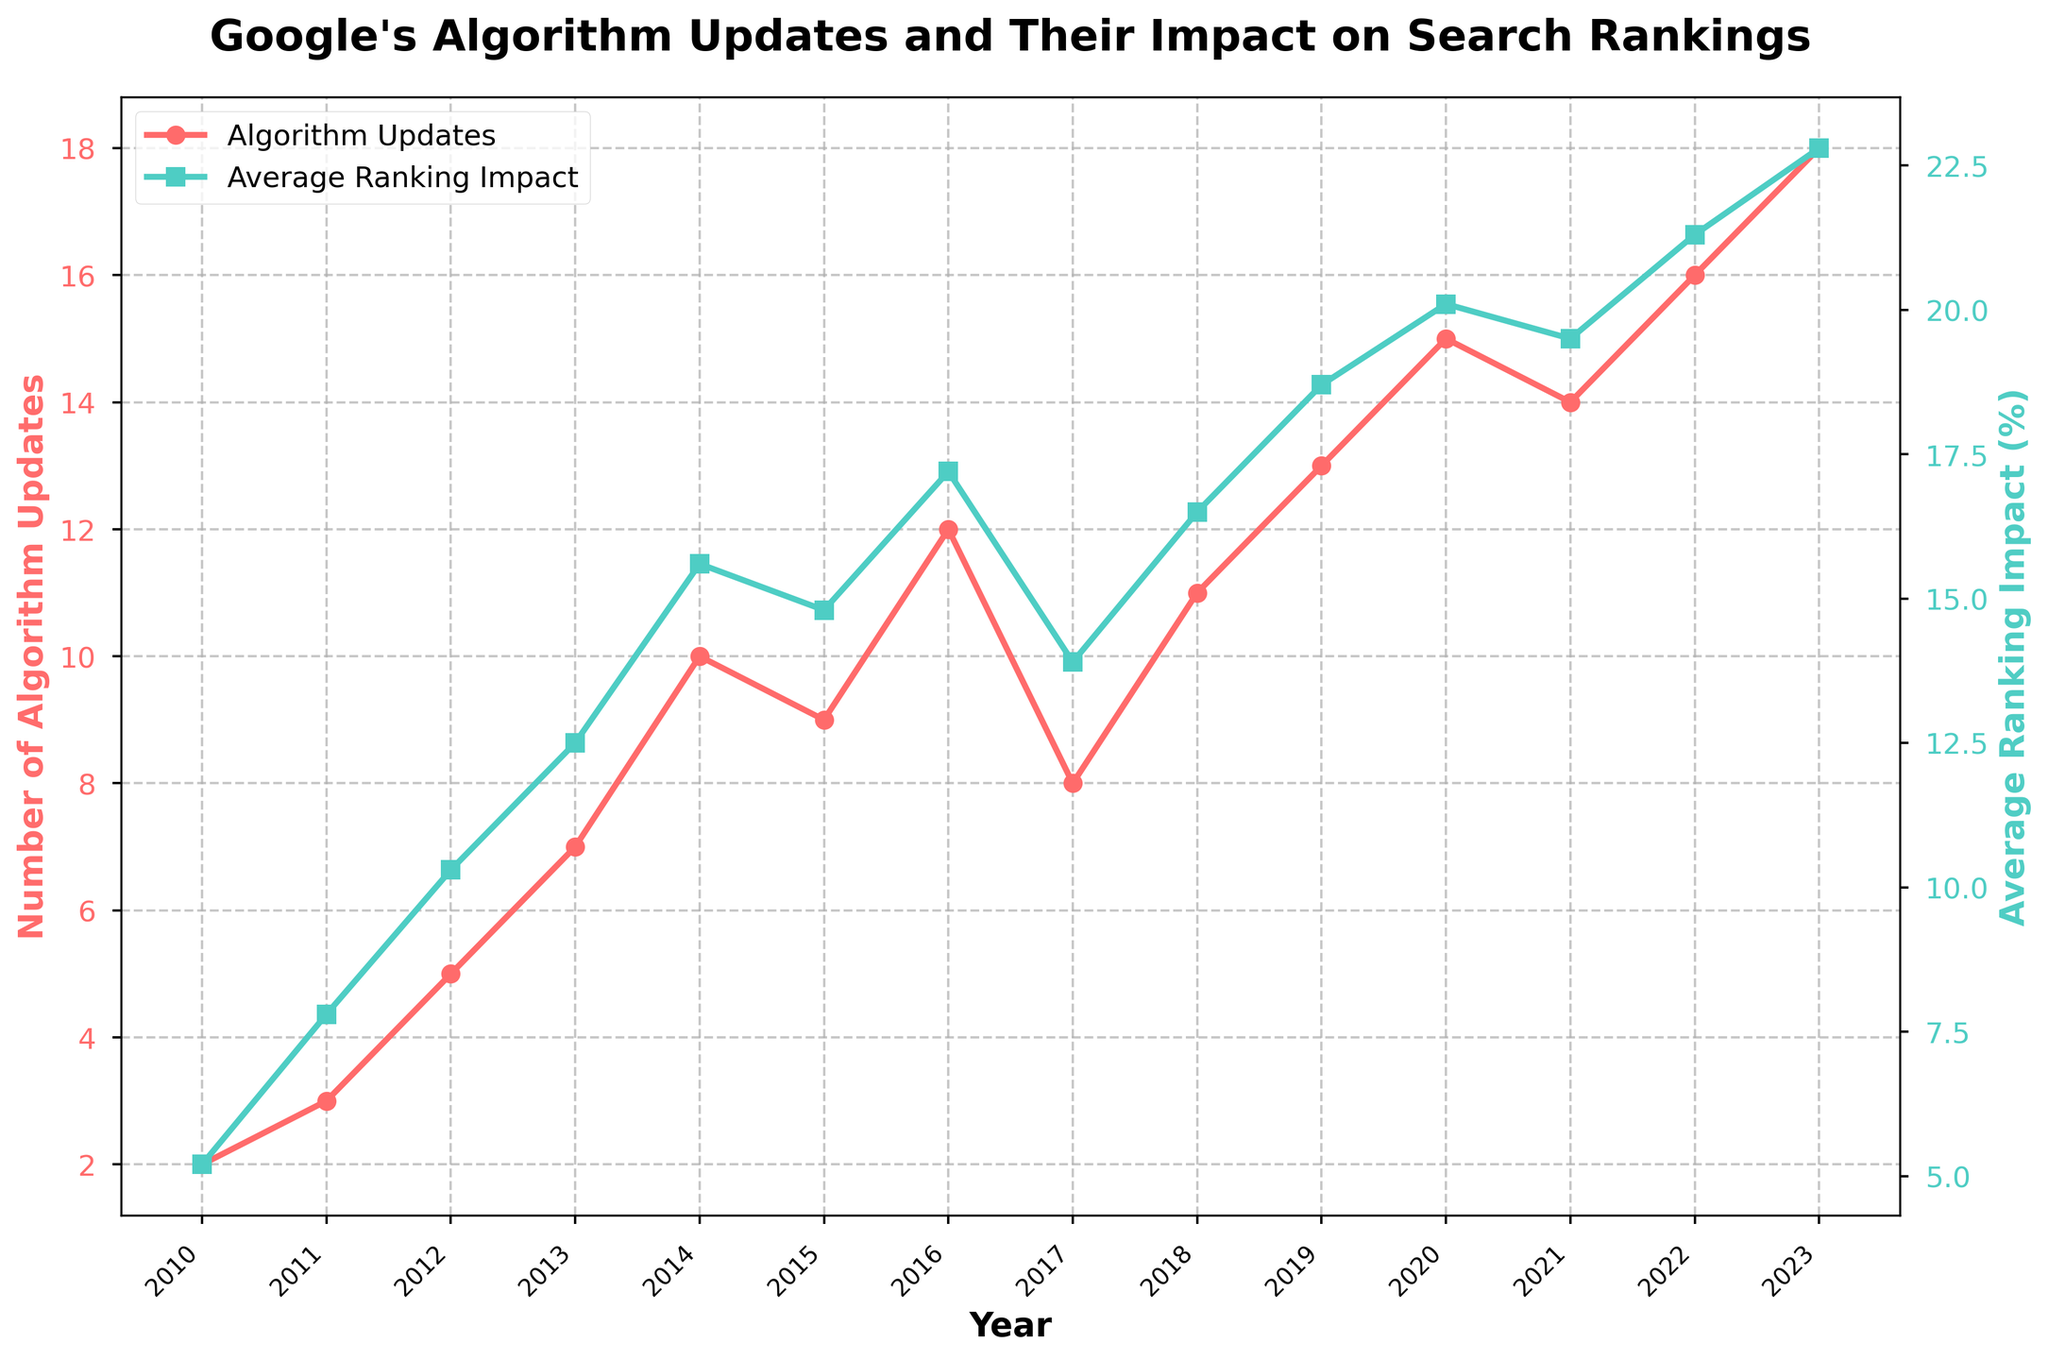What trends can you observe in the number of Google's algorithm updates over the years? The number of algorithm updates shows a general increasing trend from 2010 to 2023, with some fluctuations. Specifically, it increases from 2 in 2010 to 18 in 2023, though it dips slightly in certain years like 2015 and 2017.
Answer: Increasing trend In which year does the average ranking impact first exceed 20%? The average ranking impact first exceeds 20% in the year 2020, reaching 20.1%.
Answer: 2020 Compare the number of algorithm updates in 2015 and 2020. Which year had more updates and by how many? In 2015, there were 9 algorithm updates, while in 2020, there were 15. Therefore, 2020 had 6 more updates than 2015.
Answer: 2020 by 6 How does the average ranking impact change from 2012 to 2019? The average ranking impact increases from 10.3% in 2012 to 18.7% in 2019, showing a steady rising trend over these years.
Answer: Increased by 8.4% Which years had more than 10 algorithm updates? The years that had more than 10 algorithm updates are 2014 (10), 2016 (12), 2018 (11), 2019 (13), 2020 (15), 2021 (14), 2022 (16), and 2023 (18).
Answer: 2014, 2016, 2018, 2019, 2020, 2021, 2022, 2023 What is the general relationship between the number of algorithm updates and the average ranking impact? Generally, as the number of algorithm updates increases, the average ranking impact also tends to increase. This can be observed by the increasing trends in both lines over the years.
Answer: Positive correlation By how much did the average ranking impact percentage change between 2010 and 2023? The average ranking impact increased from 5.2% in 2010 to 22.8% in 2023. The change is 22.8 - 5.2 = 17.6%.
Answer: Increased by 17.6% In which year did the number of algorithm updates peak and what was the corresponding average ranking impact? The number of algorithm updates peaked in 2023 with 18 updates, and the corresponding average ranking impact was 22.8%.
Answer: 2023, 22.8% Visually, which color line represents the number of algorithm updates and which one represents the average ranking impact? The red line with circular markers represents the number of algorithm updates, while the green line with square markers represents the average ranking impact.
Answer: Red for updates, Green for impact 